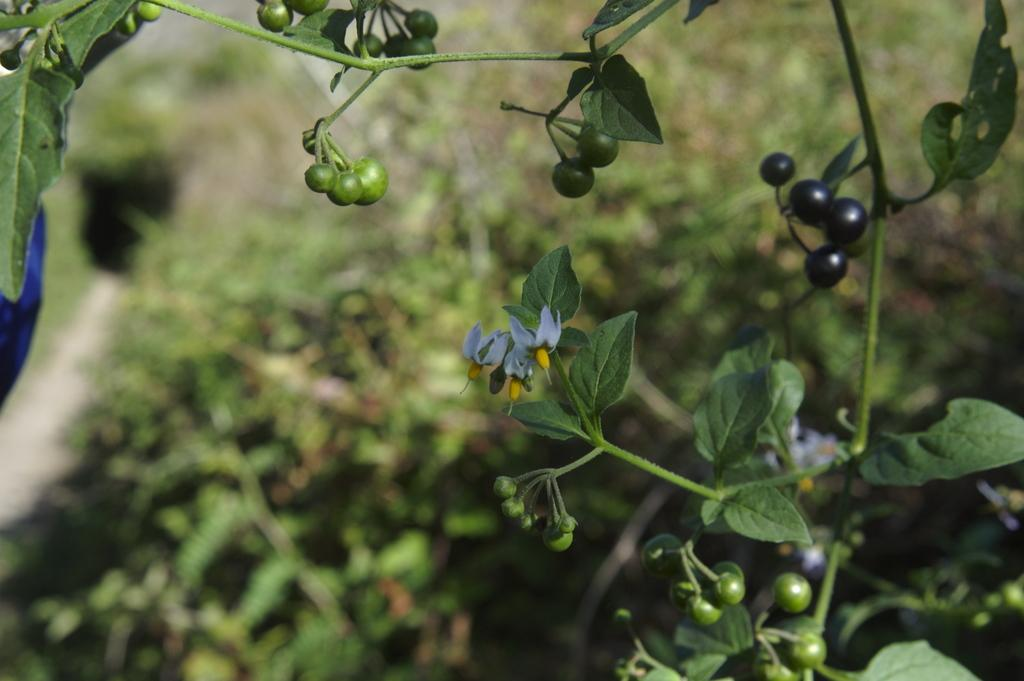What type of plant can be seen in the image? There is a tree in the image. What is present on the tree's branches? There are fruits and flowers on the branches of the tree. Where is the car parked in the image? There is no car present in the image. What type of bubble can be seen floating near the tree? There are no bubbles present in the image. 